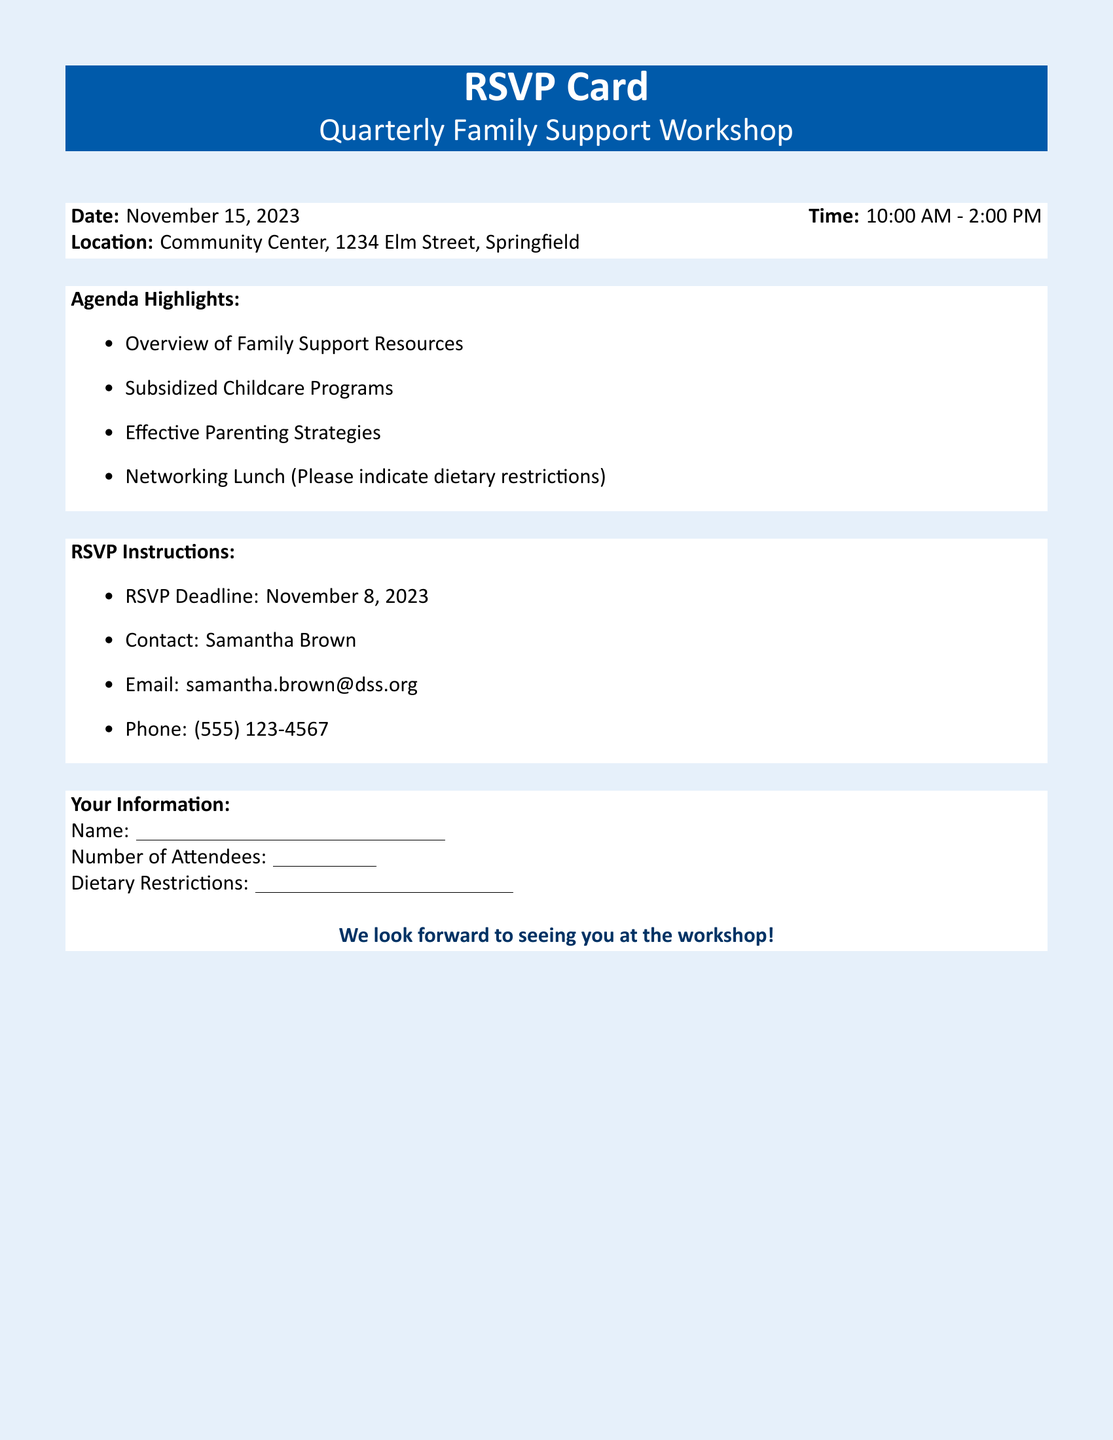What is the date of the workshop? The date of the workshop is explicitly stated in the document.
Answer: November 15, 2023 What time does the workshop start? The starting time of the workshop is mentioned in the document's details.
Answer: 10:00 AM Where is the workshop taking place? The location of the workshop is clearly provided in the document.
Answer: Community Center, 1234 Elm Street, Springfield What is one topic covered in the workshop? The agenda highlights a list of topics that will be discussed during the workshop.
Answer: Subsidized Childcare Programs Who should participants contact to RSVP? The document specifies a contact person for RSVPs.
Answer: Samantha Brown What is the deadline to RSVP? The document lists the deadline for RSVPs clearly.
Answer: November 8, 2023 How many total hours will the workshop last? The total duration of the workshop can be calculated from the starting and ending times given.
Answer: 4 hours What should attendees indicate regarding lunch? The document asks attendees to provide specific information about lunch.
Answer: Dietary restrictions 